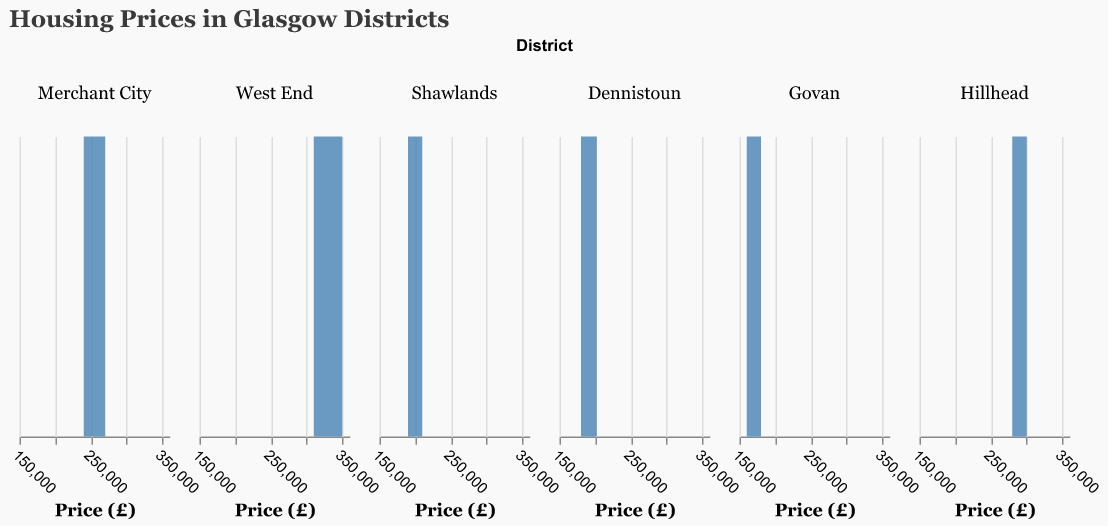What is the price range shown on the x-axis? The x-axis shows the range of housing prices on the horizontal axis. From the figure, it appears the prices range from £150,000 to £360,000.
Answer: £150,000 to £360,000 Which district has the highest peak in the density plot? By observing the peaks in the density plots across different districts, West End has the highest peak, indicating it has a dense cluster of house prices within a specific price range.
Answer: West End What does the highest peak signify in the context of this plot? The highest peak in a density plot represents the price range where the highest number of houses are concentrated within that district. For West End, this signifies a dense cluster of houses within a high price range.
Answer: Dense cluster of houses in the West End What district has the lowest price range for house prices? Observing the plots, Govan has the lowest price range, spanning from approximately £160,000 to £180,000.
Answer: Govan How do the housing prices in Merchant City compare to those in Hillhead? Merchant City prices range from £240,000 to £270,000, while Hillhead prices range from £280,000 to £300,000. Homes in Hillhead generally have higher prices compared to Merchant City.
Answer: Higher in Hillhead Which district has the widest spread of housing prices? Observing the spread of prices across different facets, the West End has the widest spread of housing prices, ranging from £310,000 to £350,000.
Answer: West End What is the common factor in the units presented on the x-axis across all districts? All units on the x-axis across different districts represent housing prices in GBP (£). This is evident by checking that the x-axis is labeled "Price (£)" in each facet.
Answer: Price in GBP (£) For Shawlands, estimate the median price based on the density plot. The density plot for Shawlands ranges from £190,000 to £210,000. By estimating the middle value of this range, the median price would be around £200,000.
Answer: £200,000 Is there any overlap in the price ranges of Dennistoun and Shawlands? By comparing the density plots, Dennistoun ranges from £180,000 to £202,000, and Shawlands ranges from £190,000 to £210,000. There is an overlap between £190,000 and £202,000.
Answer: Yes, between £190,000 and £202,000 